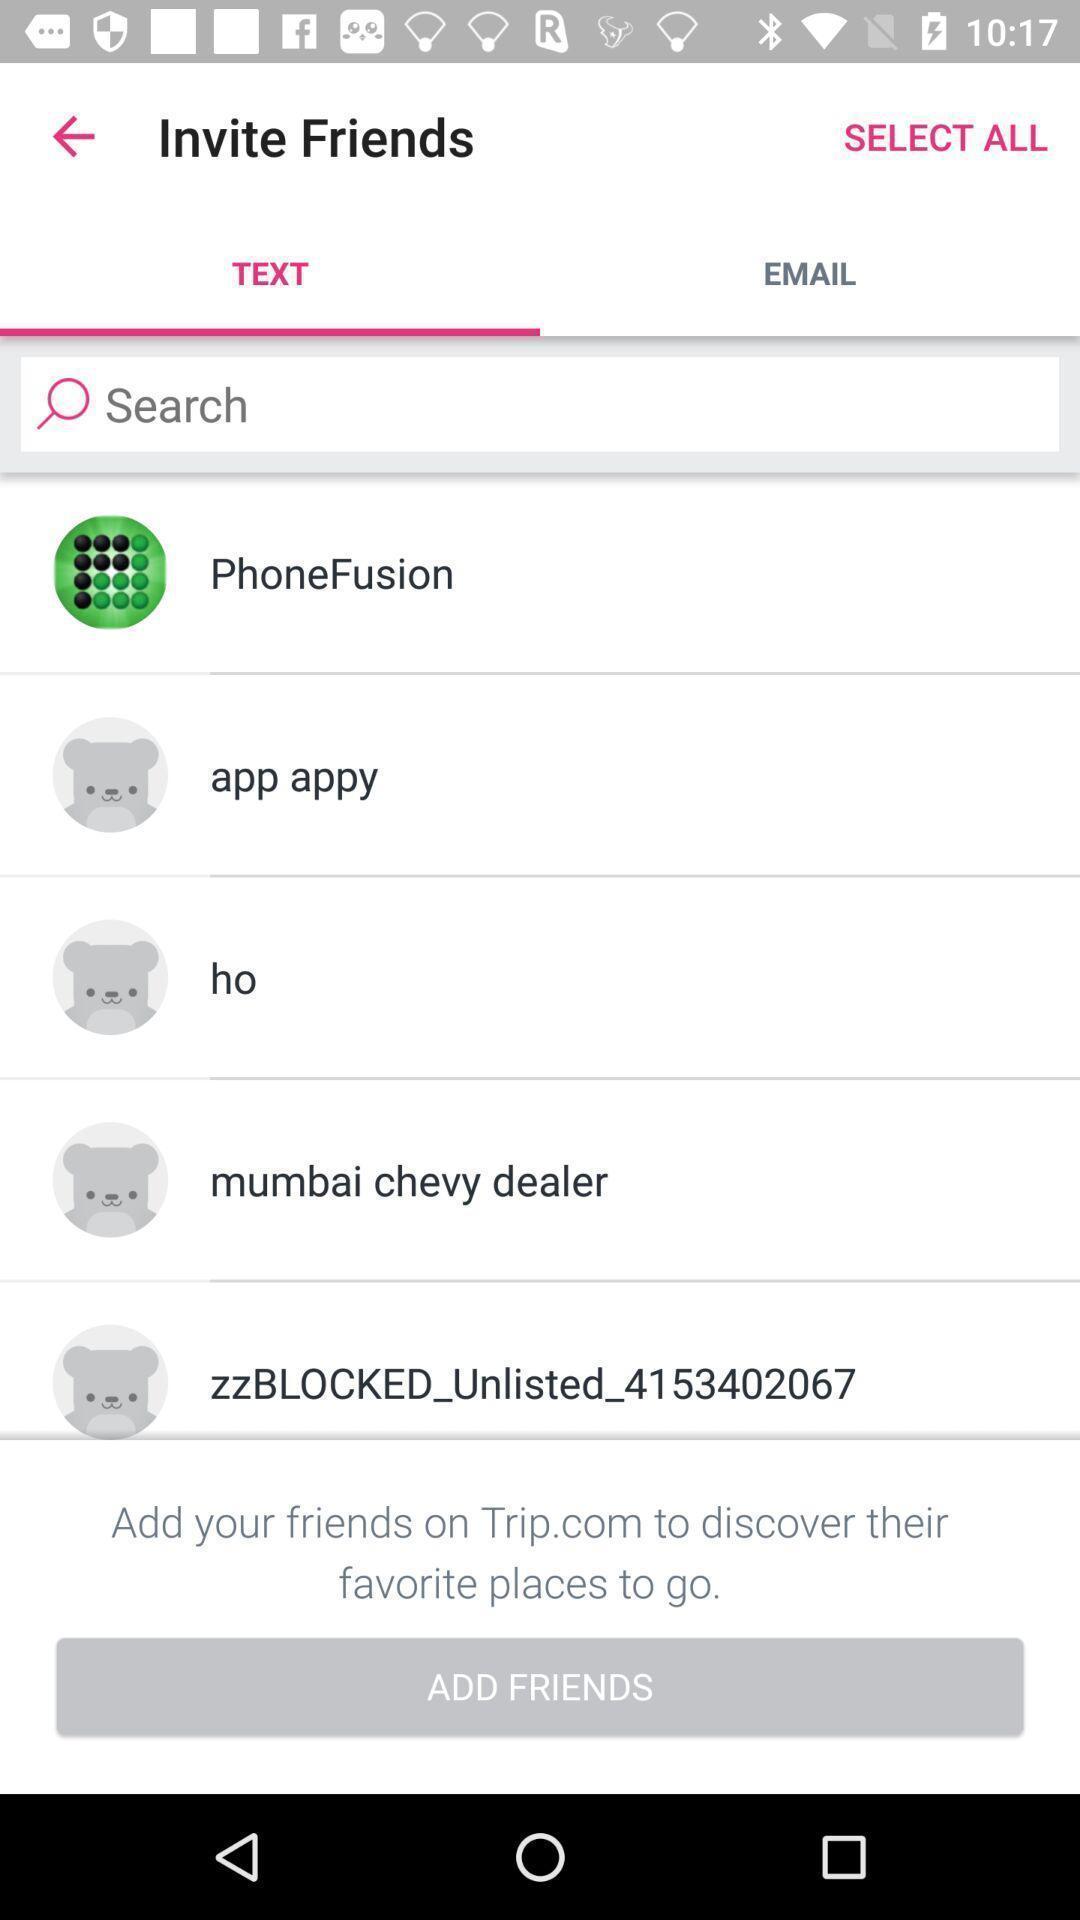What is the overall content of this screenshot? Page with list of friends to recommend an application. 